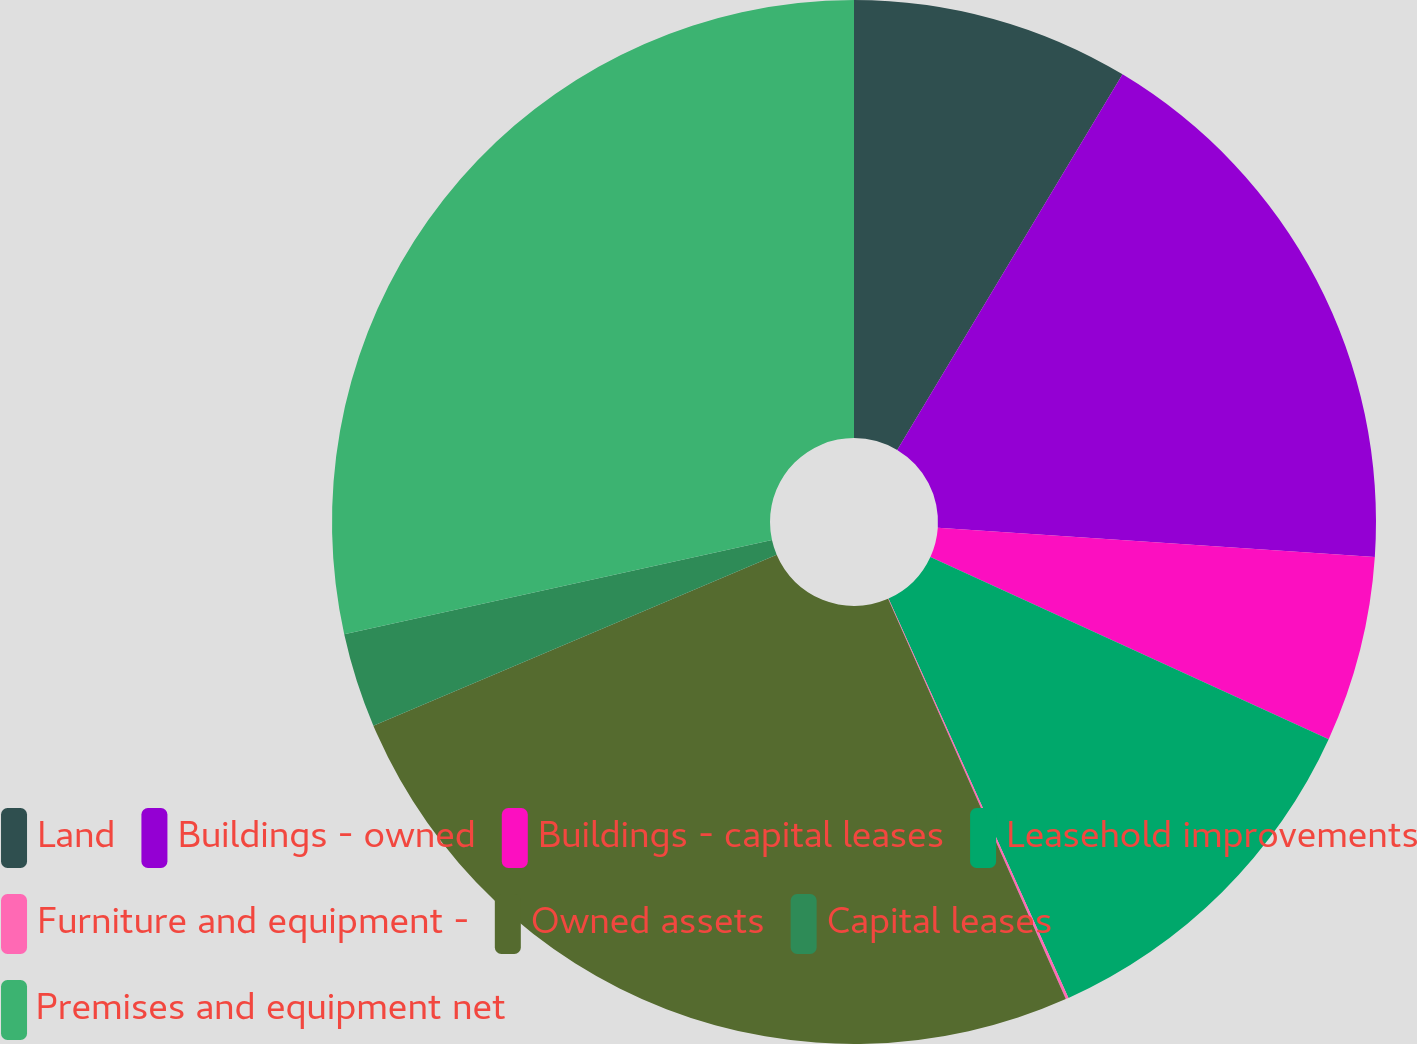Convert chart. <chart><loc_0><loc_0><loc_500><loc_500><pie_chart><fcel>Land<fcel>Buildings - owned<fcel>Buildings - capital leases<fcel>Leasehold improvements<fcel>Furniture and equipment -<fcel>Owned assets<fcel>Capital leases<fcel>Premises and equipment net<nl><fcel>8.6%<fcel>17.47%<fcel>5.76%<fcel>11.43%<fcel>0.09%<fcel>25.27%<fcel>2.93%<fcel>28.45%<nl></chart> 